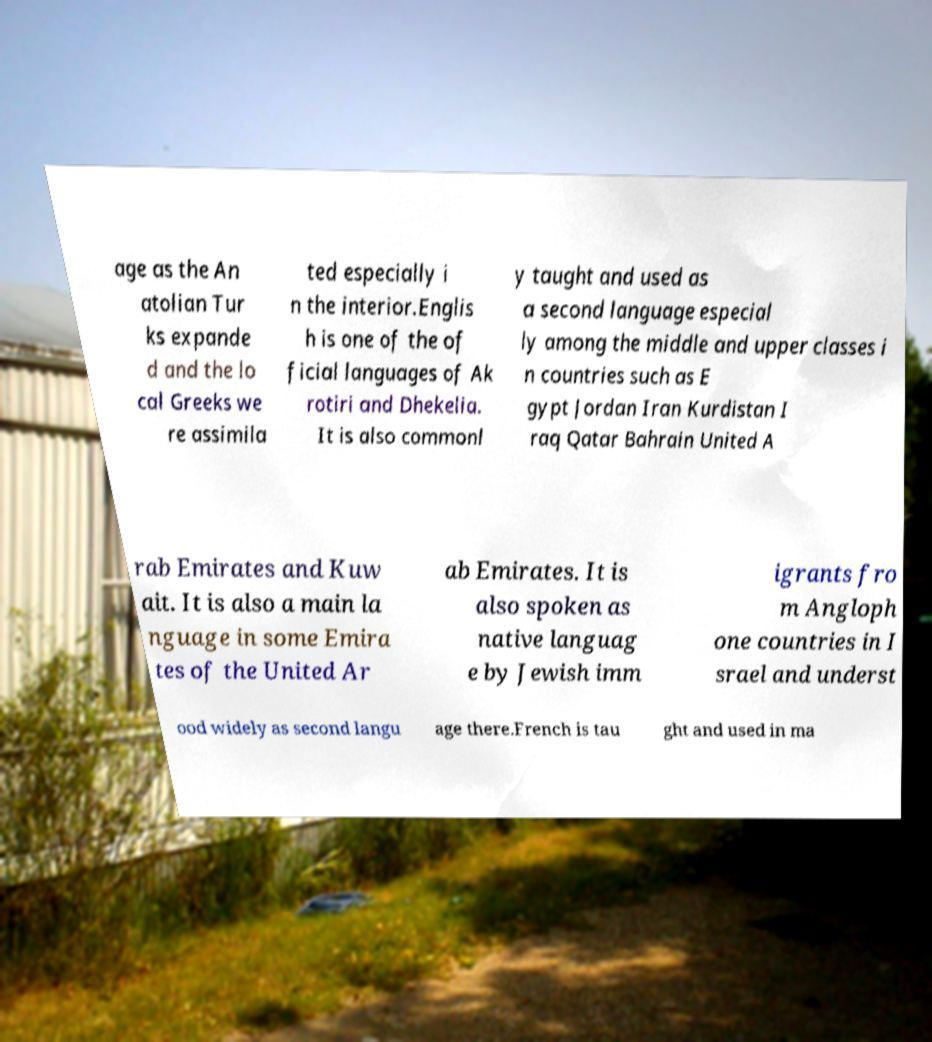I need the written content from this picture converted into text. Can you do that? age as the An atolian Tur ks expande d and the lo cal Greeks we re assimila ted especially i n the interior.Englis h is one of the of ficial languages of Ak rotiri and Dhekelia. It is also commonl y taught and used as a second language especial ly among the middle and upper classes i n countries such as E gypt Jordan Iran Kurdistan I raq Qatar Bahrain United A rab Emirates and Kuw ait. It is also a main la nguage in some Emira tes of the United Ar ab Emirates. It is also spoken as native languag e by Jewish imm igrants fro m Angloph one countries in I srael and underst ood widely as second langu age there.French is tau ght and used in ma 